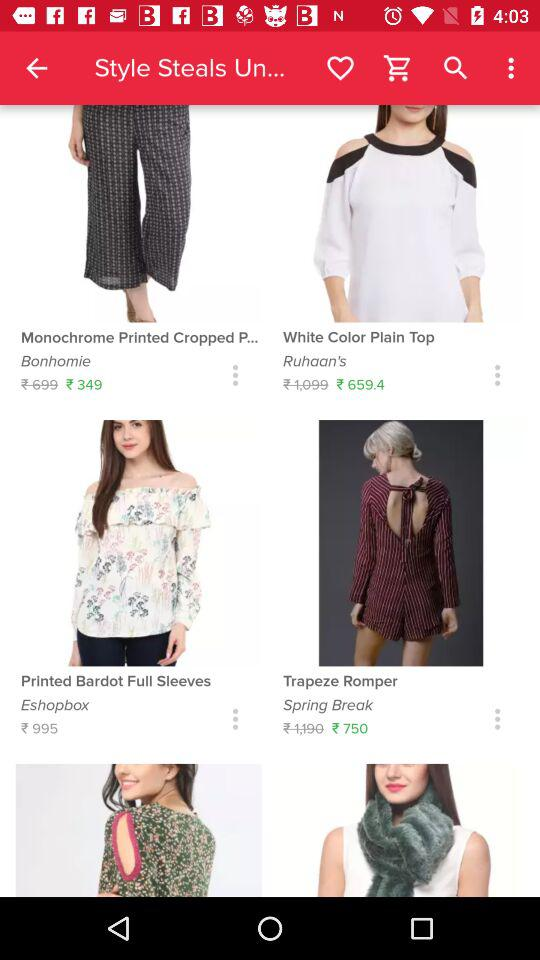What is the discounted price of "White Color Plain Top"? The discounted price of "White Color Plain Top" is ₹659.4. 